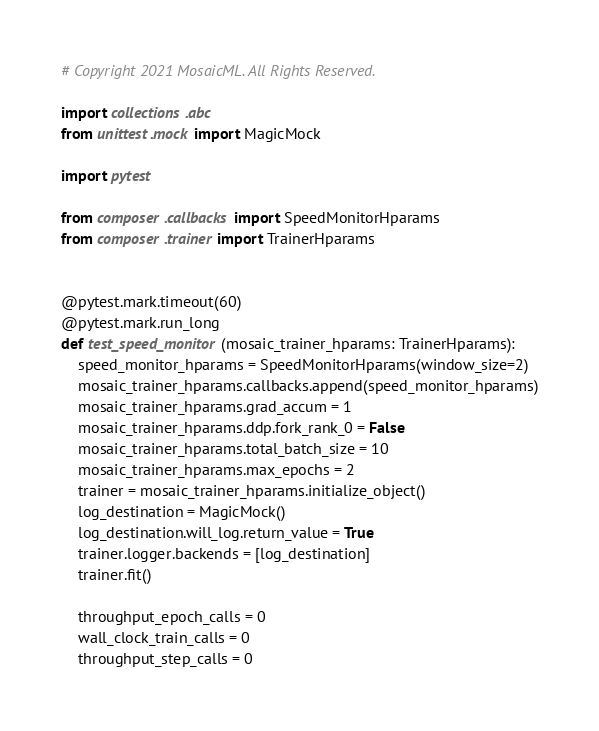Convert code to text. <code><loc_0><loc_0><loc_500><loc_500><_Python_># Copyright 2021 MosaicML. All Rights Reserved.

import collections.abc
from unittest.mock import MagicMock

import pytest

from composer.callbacks import SpeedMonitorHparams
from composer.trainer import TrainerHparams


@pytest.mark.timeout(60)
@pytest.mark.run_long
def test_speed_monitor(mosaic_trainer_hparams: TrainerHparams):
    speed_monitor_hparams = SpeedMonitorHparams(window_size=2)
    mosaic_trainer_hparams.callbacks.append(speed_monitor_hparams)
    mosaic_trainer_hparams.grad_accum = 1
    mosaic_trainer_hparams.ddp.fork_rank_0 = False
    mosaic_trainer_hparams.total_batch_size = 10
    mosaic_trainer_hparams.max_epochs = 2
    trainer = mosaic_trainer_hparams.initialize_object()
    log_destination = MagicMock()
    log_destination.will_log.return_value = True
    trainer.logger.backends = [log_destination]
    trainer.fit()

    throughput_epoch_calls = 0
    wall_clock_train_calls = 0
    throughput_step_calls = 0</code> 